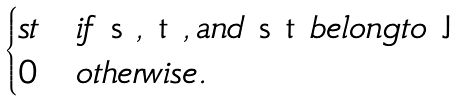Convert formula to latex. <formula><loc_0><loc_0><loc_500><loc_500>\begin{cases} s t & i f $ s $ , $ t $ , a n d $ s t $ b e l o n g t o $ J $ \\ 0 & o t h e r w i s e . \end{cases}</formula> 